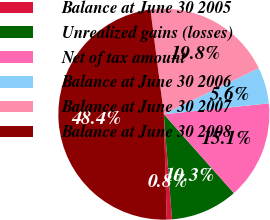Convert chart. <chart><loc_0><loc_0><loc_500><loc_500><pie_chart><fcel>Balance at June 30 2005<fcel>Unrealized gains (losses)<fcel>Net of tax amount<fcel>Balance at June 30 2006<fcel>Balance at June 30 2007<fcel>Balance at June 30 2008<nl><fcel>0.8%<fcel>10.32%<fcel>15.08%<fcel>5.56%<fcel>19.84%<fcel>48.4%<nl></chart> 